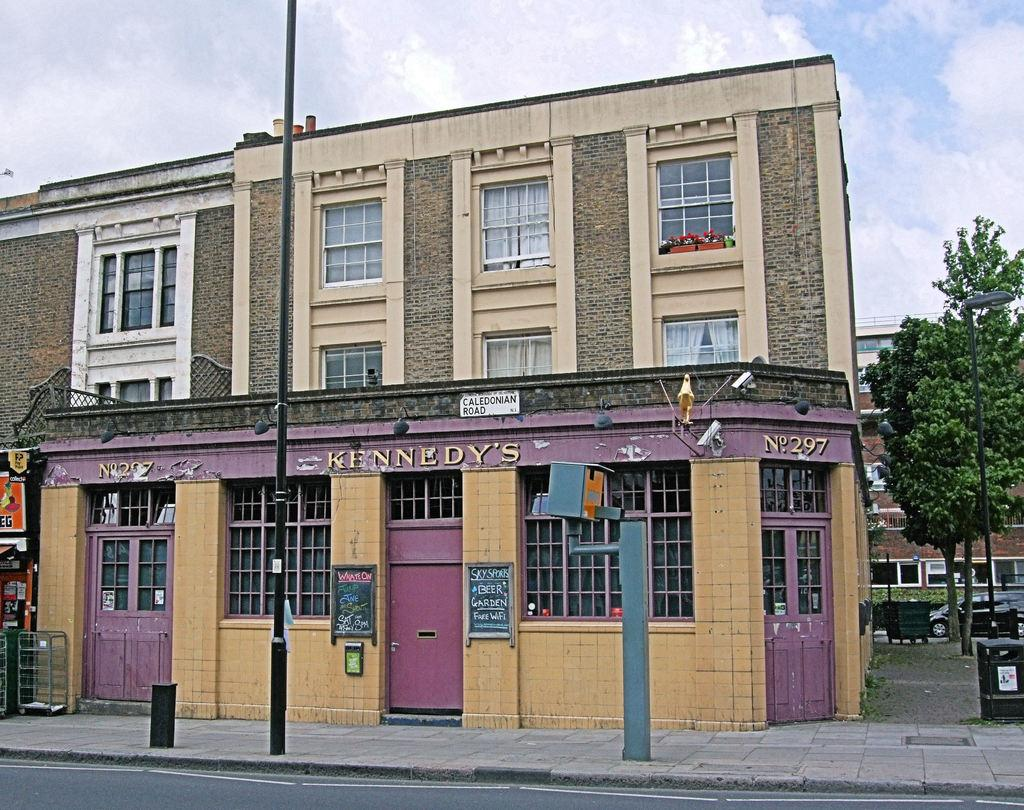What is located in the center of the image? There is a pole and a building in the center of the image. What can be seen in the background of the image? There are trees, buildings, and the sky visible in the background of the image. Are there any clouds in the sky? Yes, there are clouds in the background of the image. What type of hat is the volleyball player wearing in the image? There is no volleyball player or hat present in the image. 